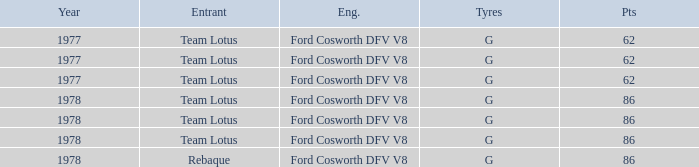What is the Focus that has a Year bigger than 1977? 86, 86, 86, 86. 